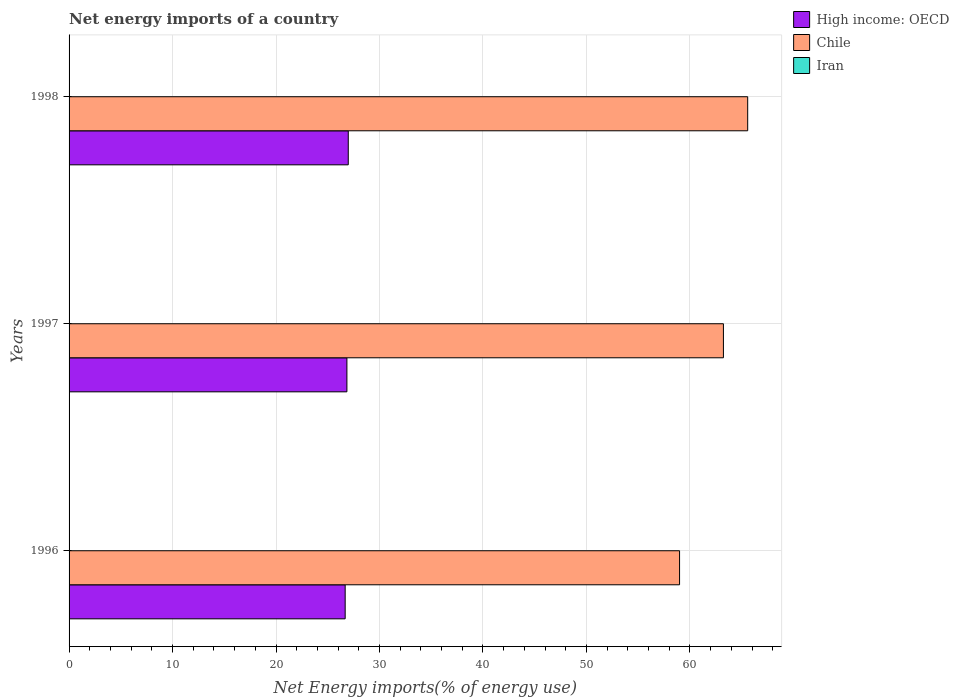How many groups of bars are there?
Your answer should be compact. 3. How many bars are there on the 3rd tick from the bottom?
Your answer should be very brief. 2. What is the label of the 3rd group of bars from the top?
Offer a terse response. 1996. What is the net energy imports in Chile in 1998?
Your response must be concise. 65.58. Across all years, what is the maximum net energy imports in High income: OECD?
Provide a short and direct response. 26.98. Across all years, what is the minimum net energy imports in High income: OECD?
Your answer should be very brief. 26.68. In which year was the net energy imports in High income: OECD maximum?
Your answer should be compact. 1998. What is the total net energy imports in High income: OECD in the graph?
Give a very brief answer. 80.52. What is the difference between the net energy imports in Chile in 1997 and that in 1998?
Offer a very short reply. -2.35. What is the difference between the net energy imports in High income: OECD in 1998 and the net energy imports in Iran in 1997?
Provide a succinct answer. 26.98. What is the average net energy imports in High income: OECD per year?
Keep it short and to the point. 26.84. In the year 1996, what is the difference between the net energy imports in Chile and net energy imports in High income: OECD?
Your answer should be very brief. 32.32. What is the ratio of the net energy imports in High income: OECD in 1996 to that in 1997?
Provide a succinct answer. 0.99. Is the net energy imports in Chile in 1996 less than that in 1997?
Provide a short and direct response. Yes. Is the difference between the net energy imports in Chile in 1997 and 1998 greater than the difference between the net energy imports in High income: OECD in 1997 and 1998?
Ensure brevity in your answer.  No. What is the difference between the highest and the second highest net energy imports in High income: OECD?
Your answer should be compact. 0.13. What is the difference between the highest and the lowest net energy imports in Chile?
Give a very brief answer. 6.58. In how many years, is the net energy imports in Iran greater than the average net energy imports in Iran taken over all years?
Provide a succinct answer. 0. Is the sum of the net energy imports in High income: OECD in 1997 and 1998 greater than the maximum net energy imports in Iran across all years?
Your answer should be compact. Yes. Are all the bars in the graph horizontal?
Your answer should be very brief. Yes. How many years are there in the graph?
Offer a terse response. 3. Does the graph contain grids?
Keep it short and to the point. Yes. How are the legend labels stacked?
Your answer should be compact. Vertical. What is the title of the graph?
Offer a terse response. Net energy imports of a country. Does "Uruguay" appear as one of the legend labels in the graph?
Give a very brief answer. No. What is the label or title of the X-axis?
Offer a terse response. Net Energy imports(% of energy use). What is the label or title of the Y-axis?
Your answer should be very brief. Years. What is the Net Energy imports(% of energy use) of High income: OECD in 1996?
Provide a succinct answer. 26.68. What is the Net Energy imports(% of energy use) in Chile in 1996?
Ensure brevity in your answer.  59. What is the Net Energy imports(% of energy use) of Iran in 1996?
Give a very brief answer. 0. What is the Net Energy imports(% of energy use) of High income: OECD in 1997?
Your answer should be compact. 26.85. What is the Net Energy imports(% of energy use) of Chile in 1997?
Give a very brief answer. 63.24. What is the Net Energy imports(% of energy use) in Iran in 1997?
Make the answer very short. 0. What is the Net Energy imports(% of energy use) in High income: OECD in 1998?
Offer a very short reply. 26.98. What is the Net Energy imports(% of energy use) of Chile in 1998?
Provide a succinct answer. 65.58. What is the Net Energy imports(% of energy use) of Iran in 1998?
Provide a short and direct response. 0. Across all years, what is the maximum Net Energy imports(% of energy use) of High income: OECD?
Your response must be concise. 26.98. Across all years, what is the maximum Net Energy imports(% of energy use) in Chile?
Make the answer very short. 65.58. Across all years, what is the minimum Net Energy imports(% of energy use) in High income: OECD?
Keep it short and to the point. 26.68. Across all years, what is the minimum Net Energy imports(% of energy use) of Chile?
Your answer should be compact. 59. What is the total Net Energy imports(% of energy use) in High income: OECD in the graph?
Ensure brevity in your answer.  80.52. What is the total Net Energy imports(% of energy use) of Chile in the graph?
Offer a terse response. 187.82. What is the total Net Energy imports(% of energy use) in Iran in the graph?
Your answer should be compact. 0. What is the difference between the Net Energy imports(% of energy use) in High income: OECD in 1996 and that in 1997?
Your answer should be compact. -0.17. What is the difference between the Net Energy imports(% of energy use) in Chile in 1996 and that in 1997?
Your answer should be compact. -4.24. What is the difference between the Net Energy imports(% of energy use) in High income: OECD in 1996 and that in 1998?
Your answer should be compact. -0.3. What is the difference between the Net Energy imports(% of energy use) of Chile in 1996 and that in 1998?
Offer a very short reply. -6.58. What is the difference between the Net Energy imports(% of energy use) of High income: OECD in 1997 and that in 1998?
Your answer should be compact. -0.13. What is the difference between the Net Energy imports(% of energy use) of Chile in 1997 and that in 1998?
Provide a succinct answer. -2.35. What is the difference between the Net Energy imports(% of energy use) of High income: OECD in 1996 and the Net Energy imports(% of energy use) of Chile in 1997?
Offer a terse response. -36.56. What is the difference between the Net Energy imports(% of energy use) of High income: OECD in 1996 and the Net Energy imports(% of energy use) of Chile in 1998?
Your answer should be very brief. -38.9. What is the difference between the Net Energy imports(% of energy use) of High income: OECD in 1997 and the Net Energy imports(% of energy use) of Chile in 1998?
Keep it short and to the point. -38.73. What is the average Net Energy imports(% of energy use) in High income: OECD per year?
Ensure brevity in your answer.  26.84. What is the average Net Energy imports(% of energy use) of Chile per year?
Keep it short and to the point. 62.61. What is the average Net Energy imports(% of energy use) in Iran per year?
Give a very brief answer. 0. In the year 1996, what is the difference between the Net Energy imports(% of energy use) in High income: OECD and Net Energy imports(% of energy use) in Chile?
Offer a very short reply. -32.32. In the year 1997, what is the difference between the Net Energy imports(% of energy use) in High income: OECD and Net Energy imports(% of energy use) in Chile?
Ensure brevity in your answer.  -36.39. In the year 1998, what is the difference between the Net Energy imports(% of energy use) of High income: OECD and Net Energy imports(% of energy use) of Chile?
Provide a short and direct response. -38.6. What is the ratio of the Net Energy imports(% of energy use) in High income: OECD in 1996 to that in 1997?
Provide a short and direct response. 0.99. What is the ratio of the Net Energy imports(% of energy use) in Chile in 1996 to that in 1997?
Give a very brief answer. 0.93. What is the ratio of the Net Energy imports(% of energy use) of High income: OECD in 1996 to that in 1998?
Give a very brief answer. 0.99. What is the ratio of the Net Energy imports(% of energy use) of Chile in 1996 to that in 1998?
Make the answer very short. 0.9. What is the ratio of the Net Energy imports(% of energy use) in High income: OECD in 1997 to that in 1998?
Your answer should be compact. 1. What is the ratio of the Net Energy imports(% of energy use) of Chile in 1997 to that in 1998?
Keep it short and to the point. 0.96. What is the difference between the highest and the second highest Net Energy imports(% of energy use) of High income: OECD?
Your response must be concise. 0.13. What is the difference between the highest and the second highest Net Energy imports(% of energy use) in Chile?
Give a very brief answer. 2.35. What is the difference between the highest and the lowest Net Energy imports(% of energy use) of High income: OECD?
Ensure brevity in your answer.  0.3. What is the difference between the highest and the lowest Net Energy imports(% of energy use) in Chile?
Keep it short and to the point. 6.58. 